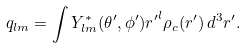<formula> <loc_0><loc_0><loc_500><loc_500>q _ { l m } = \int Y _ { l m } ^ { * } ( \theta ^ { \prime } , \phi ^ { \prime } ) { r ^ { \prime } } ^ { l } \rho _ { c } ( { r } ^ { \prime } ) \, d ^ { 3 } r ^ { \prime } .</formula> 